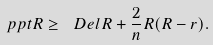<formula> <loc_0><loc_0><loc_500><loc_500>\ p p t R \geq \ D e l R + \frac { 2 } { n } R ( R - r ) .</formula> 